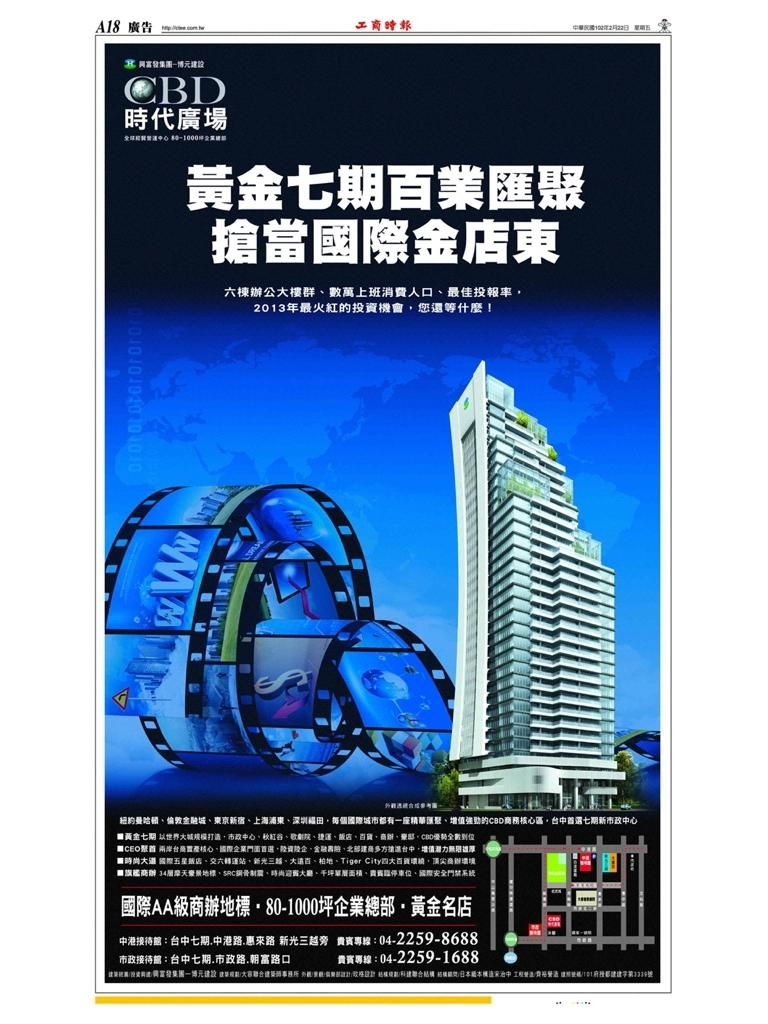<image>
Render a clear and concise summary of the photo. An advertisement that says CBD on top of it and has a building and other words written in what appears to be Chinese. 